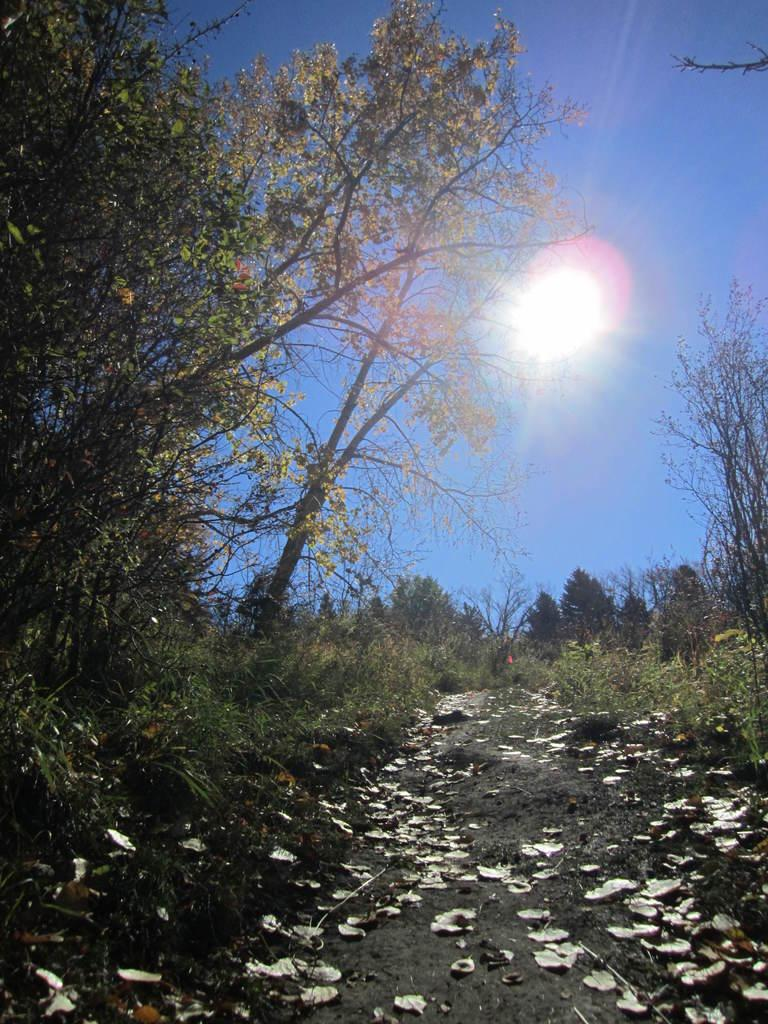What type of vegetation can be seen on the ground in the image? There are dry leaves and grass on the ground in the image. How many trees are visible in the image? There are many trees in the image. What is visible behind the trees in the image? The sky is visible behind the trees in the image. What celestial body can be seen in the sky? The sun is present in the sky. Can you tell me how many deer are standing near the trees in the image? There are no deer present in the image; it features dry leaves, grass, trees, and the sky. What type of offer is being made by the sun in the image? The sun is not making any offer in the image; it is simply a celestial body visible in the sky. 